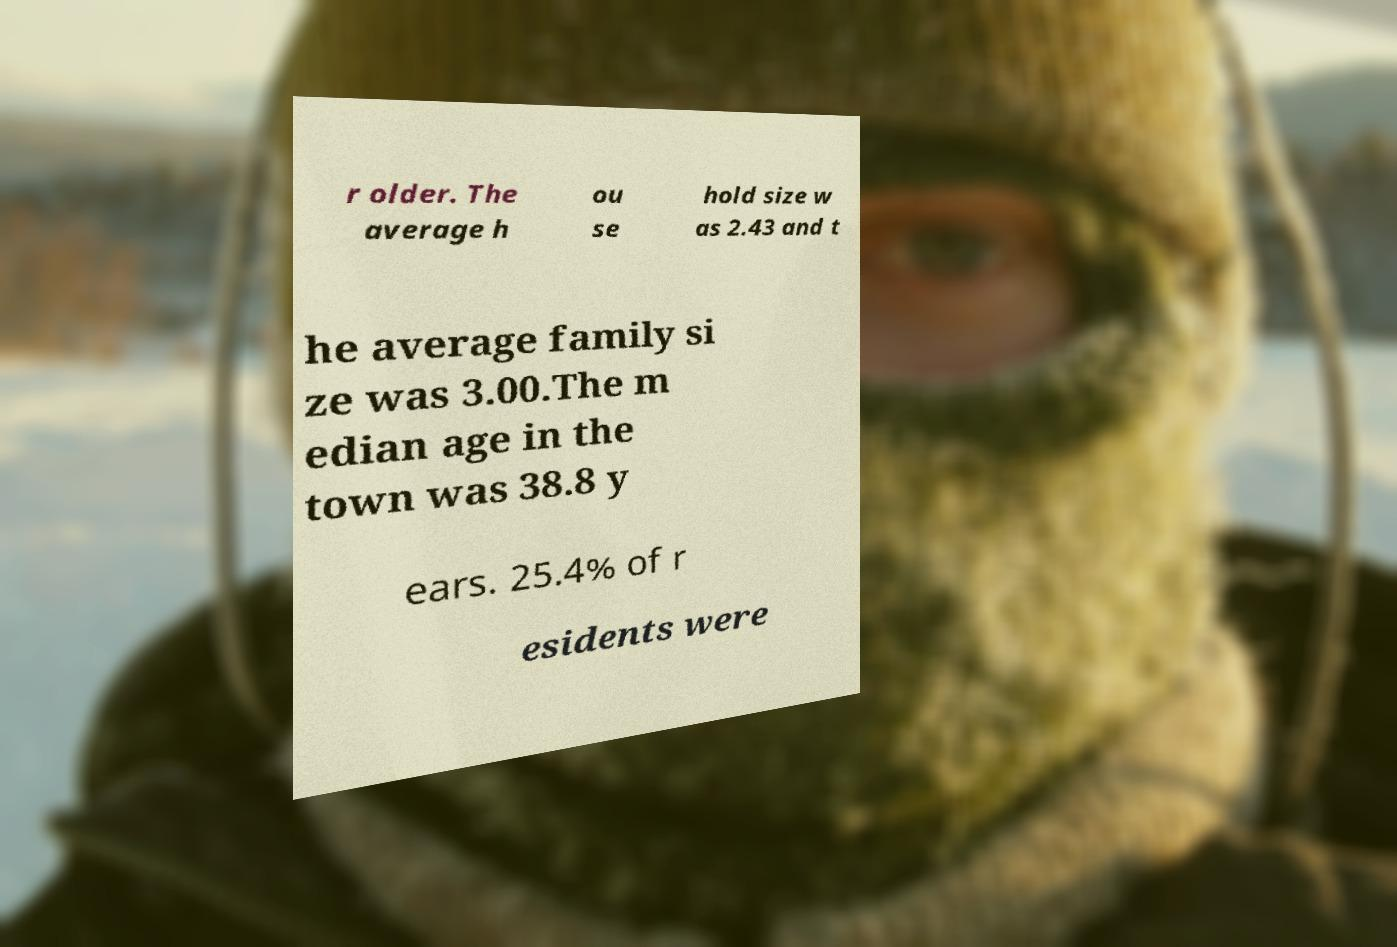I need the written content from this picture converted into text. Can you do that? r older. The average h ou se hold size w as 2.43 and t he average family si ze was 3.00.The m edian age in the town was 38.8 y ears. 25.4% of r esidents were 